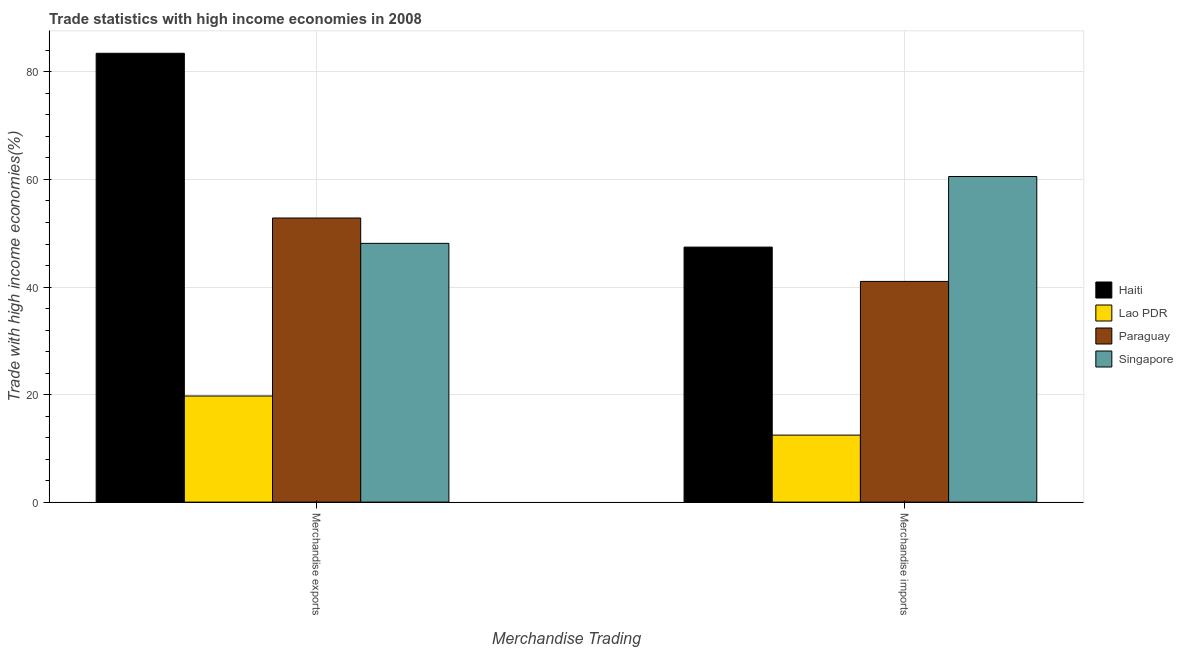How many different coloured bars are there?
Ensure brevity in your answer.  4. How many groups of bars are there?
Your answer should be compact. 2. Are the number of bars on each tick of the X-axis equal?
Offer a very short reply. Yes. How many bars are there on the 2nd tick from the left?
Give a very brief answer. 4. How many bars are there on the 2nd tick from the right?
Your answer should be compact. 4. What is the merchandise exports in Lao PDR?
Provide a succinct answer. 19.74. Across all countries, what is the maximum merchandise imports?
Keep it short and to the point. 60.55. Across all countries, what is the minimum merchandise imports?
Your response must be concise. 12.46. In which country was the merchandise exports maximum?
Keep it short and to the point. Haiti. In which country was the merchandise imports minimum?
Offer a very short reply. Lao PDR. What is the total merchandise imports in the graph?
Provide a succinct answer. 161.48. What is the difference between the merchandise imports in Paraguay and that in Lao PDR?
Your answer should be compact. 28.58. What is the difference between the merchandise imports in Haiti and the merchandise exports in Paraguay?
Offer a very short reply. -5.41. What is the average merchandise exports per country?
Your answer should be compact. 51.04. What is the difference between the merchandise exports and merchandise imports in Haiti?
Your answer should be compact. 36.05. In how many countries, is the merchandise exports greater than 48 %?
Your answer should be compact. 3. What is the ratio of the merchandise exports in Paraguay to that in Haiti?
Your answer should be very brief. 0.63. Is the merchandise imports in Lao PDR less than that in Paraguay?
Ensure brevity in your answer.  Yes. In how many countries, is the merchandise imports greater than the average merchandise imports taken over all countries?
Your answer should be very brief. 3. What does the 1st bar from the left in Merchandise exports represents?
Provide a succinct answer. Haiti. What does the 4th bar from the right in Merchandise exports represents?
Offer a very short reply. Haiti. Are the values on the major ticks of Y-axis written in scientific E-notation?
Offer a terse response. No. Does the graph contain any zero values?
Give a very brief answer. No. Does the graph contain grids?
Offer a very short reply. Yes. Where does the legend appear in the graph?
Offer a terse response. Center right. How many legend labels are there?
Offer a very short reply. 4. What is the title of the graph?
Give a very brief answer. Trade statistics with high income economies in 2008. Does "Papua New Guinea" appear as one of the legend labels in the graph?
Your answer should be compact. No. What is the label or title of the X-axis?
Your answer should be very brief. Merchandise Trading. What is the label or title of the Y-axis?
Your response must be concise. Trade with high income economies(%). What is the Trade with high income economies(%) in Haiti in Merchandise exports?
Offer a very short reply. 83.47. What is the Trade with high income economies(%) of Lao PDR in Merchandise exports?
Provide a succinct answer. 19.74. What is the Trade with high income economies(%) in Paraguay in Merchandise exports?
Your answer should be very brief. 52.84. What is the Trade with high income economies(%) of Singapore in Merchandise exports?
Offer a terse response. 48.12. What is the Trade with high income economies(%) in Haiti in Merchandise imports?
Offer a terse response. 47.43. What is the Trade with high income economies(%) in Lao PDR in Merchandise imports?
Your answer should be very brief. 12.46. What is the Trade with high income economies(%) of Paraguay in Merchandise imports?
Ensure brevity in your answer.  41.04. What is the Trade with high income economies(%) in Singapore in Merchandise imports?
Your response must be concise. 60.55. Across all Merchandise Trading, what is the maximum Trade with high income economies(%) of Haiti?
Offer a terse response. 83.47. Across all Merchandise Trading, what is the maximum Trade with high income economies(%) of Lao PDR?
Keep it short and to the point. 19.74. Across all Merchandise Trading, what is the maximum Trade with high income economies(%) in Paraguay?
Keep it short and to the point. 52.84. Across all Merchandise Trading, what is the maximum Trade with high income economies(%) in Singapore?
Offer a terse response. 60.55. Across all Merchandise Trading, what is the minimum Trade with high income economies(%) in Haiti?
Provide a succinct answer. 47.43. Across all Merchandise Trading, what is the minimum Trade with high income economies(%) in Lao PDR?
Give a very brief answer. 12.46. Across all Merchandise Trading, what is the minimum Trade with high income economies(%) of Paraguay?
Offer a very short reply. 41.04. Across all Merchandise Trading, what is the minimum Trade with high income economies(%) of Singapore?
Make the answer very short. 48.12. What is the total Trade with high income economies(%) of Haiti in the graph?
Ensure brevity in your answer.  130.9. What is the total Trade with high income economies(%) of Lao PDR in the graph?
Your answer should be very brief. 32.2. What is the total Trade with high income economies(%) of Paraguay in the graph?
Give a very brief answer. 93.88. What is the total Trade with high income economies(%) in Singapore in the graph?
Make the answer very short. 108.68. What is the difference between the Trade with high income economies(%) of Haiti in Merchandise exports and that in Merchandise imports?
Offer a very short reply. 36.05. What is the difference between the Trade with high income economies(%) in Lao PDR in Merchandise exports and that in Merchandise imports?
Make the answer very short. 7.28. What is the difference between the Trade with high income economies(%) of Paraguay in Merchandise exports and that in Merchandise imports?
Make the answer very short. 11.79. What is the difference between the Trade with high income economies(%) of Singapore in Merchandise exports and that in Merchandise imports?
Ensure brevity in your answer.  -12.43. What is the difference between the Trade with high income economies(%) in Haiti in Merchandise exports and the Trade with high income economies(%) in Lao PDR in Merchandise imports?
Your answer should be very brief. 71.01. What is the difference between the Trade with high income economies(%) in Haiti in Merchandise exports and the Trade with high income economies(%) in Paraguay in Merchandise imports?
Provide a short and direct response. 42.43. What is the difference between the Trade with high income economies(%) of Haiti in Merchandise exports and the Trade with high income economies(%) of Singapore in Merchandise imports?
Offer a very short reply. 22.92. What is the difference between the Trade with high income economies(%) of Lao PDR in Merchandise exports and the Trade with high income economies(%) of Paraguay in Merchandise imports?
Provide a short and direct response. -21.31. What is the difference between the Trade with high income economies(%) in Lao PDR in Merchandise exports and the Trade with high income economies(%) in Singapore in Merchandise imports?
Your answer should be compact. -40.82. What is the difference between the Trade with high income economies(%) of Paraguay in Merchandise exports and the Trade with high income economies(%) of Singapore in Merchandise imports?
Provide a succinct answer. -7.72. What is the average Trade with high income economies(%) in Haiti per Merchandise Trading?
Offer a terse response. 65.45. What is the average Trade with high income economies(%) of Lao PDR per Merchandise Trading?
Your answer should be compact. 16.1. What is the average Trade with high income economies(%) in Paraguay per Merchandise Trading?
Your response must be concise. 46.94. What is the average Trade with high income economies(%) in Singapore per Merchandise Trading?
Make the answer very short. 54.34. What is the difference between the Trade with high income economies(%) of Haiti and Trade with high income economies(%) of Lao PDR in Merchandise exports?
Provide a succinct answer. 63.73. What is the difference between the Trade with high income economies(%) of Haiti and Trade with high income economies(%) of Paraguay in Merchandise exports?
Your response must be concise. 30.64. What is the difference between the Trade with high income economies(%) in Haiti and Trade with high income economies(%) in Singapore in Merchandise exports?
Your response must be concise. 35.35. What is the difference between the Trade with high income economies(%) of Lao PDR and Trade with high income economies(%) of Paraguay in Merchandise exports?
Ensure brevity in your answer.  -33.1. What is the difference between the Trade with high income economies(%) in Lao PDR and Trade with high income economies(%) in Singapore in Merchandise exports?
Provide a succinct answer. -28.38. What is the difference between the Trade with high income economies(%) in Paraguay and Trade with high income economies(%) in Singapore in Merchandise exports?
Make the answer very short. 4.71. What is the difference between the Trade with high income economies(%) of Haiti and Trade with high income economies(%) of Lao PDR in Merchandise imports?
Ensure brevity in your answer.  34.96. What is the difference between the Trade with high income economies(%) in Haiti and Trade with high income economies(%) in Paraguay in Merchandise imports?
Your answer should be compact. 6.38. What is the difference between the Trade with high income economies(%) in Haiti and Trade with high income economies(%) in Singapore in Merchandise imports?
Your response must be concise. -13.13. What is the difference between the Trade with high income economies(%) in Lao PDR and Trade with high income economies(%) in Paraguay in Merchandise imports?
Offer a very short reply. -28.58. What is the difference between the Trade with high income economies(%) of Lao PDR and Trade with high income economies(%) of Singapore in Merchandise imports?
Offer a very short reply. -48.09. What is the difference between the Trade with high income economies(%) in Paraguay and Trade with high income economies(%) in Singapore in Merchandise imports?
Your answer should be compact. -19.51. What is the ratio of the Trade with high income economies(%) in Haiti in Merchandise exports to that in Merchandise imports?
Your response must be concise. 1.76. What is the ratio of the Trade with high income economies(%) of Lao PDR in Merchandise exports to that in Merchandise imports?
Ensure brevity in your answer.  1.58. What is the ratio of the Trade with high income economies(%) of Paraguay in Merchandise exports to that in Merchandise imports?
Make the answer very short. 1.29. What is the ratio of the Trade with high income economies(%) of Singapore in Merchandise exports to that in Merchandise imports?
Make the answer very short. 0.79. What is the difference between the highest and the second highest Trade with high income economies(%) of Haiti?
Ensure brevity in your answer.  36.05. What is the difference between the highest and the second highest Trade with high income economies(%) of Lao PDR?
Your answer should be compact. 7.28. What is the difference between the highest and the second highest Trade with high income economies(%) in Paraguay?
Offer a terse response. 11.79. What is the difference between the highest and the second highest Trade with high income economies(%) in Singapore?
Ensure brevity in your answer.  12.43. What is the difference between the highest and the lowest Trade with high income economies(%) of Haiti?
Make the answer very short. 36.05. What is the difference between the highest and the lowest Trade with high income economies(%) of Lao PDR?
Provide a short and direct response. 7.28. What is the difference between the highest and the lowest Trade with high income economies(%) of Paraguay?
Your answer should be very brief. 11.79. What is the difference between the highest and the lowest Trade with high income economies(%) of Singapore?
Ensure brevity in your answer.  12.43. 